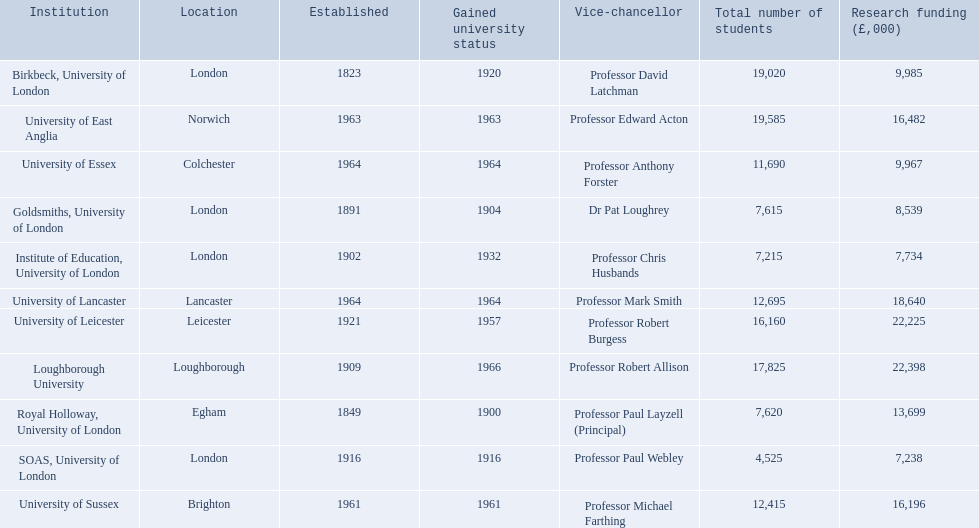What are the institutions in the 1994 group? Birkbeck, University of London, University of East Anglia, University of Essex, Goldsmiths, University of London, Institute of Education, University of London, University of Lancaster, University of Leicester, Loughborough University, Royal Holloway, University of London, SOAS, University of London, University of Sussex. Which of these was made a university most recently? Loughborough University. 